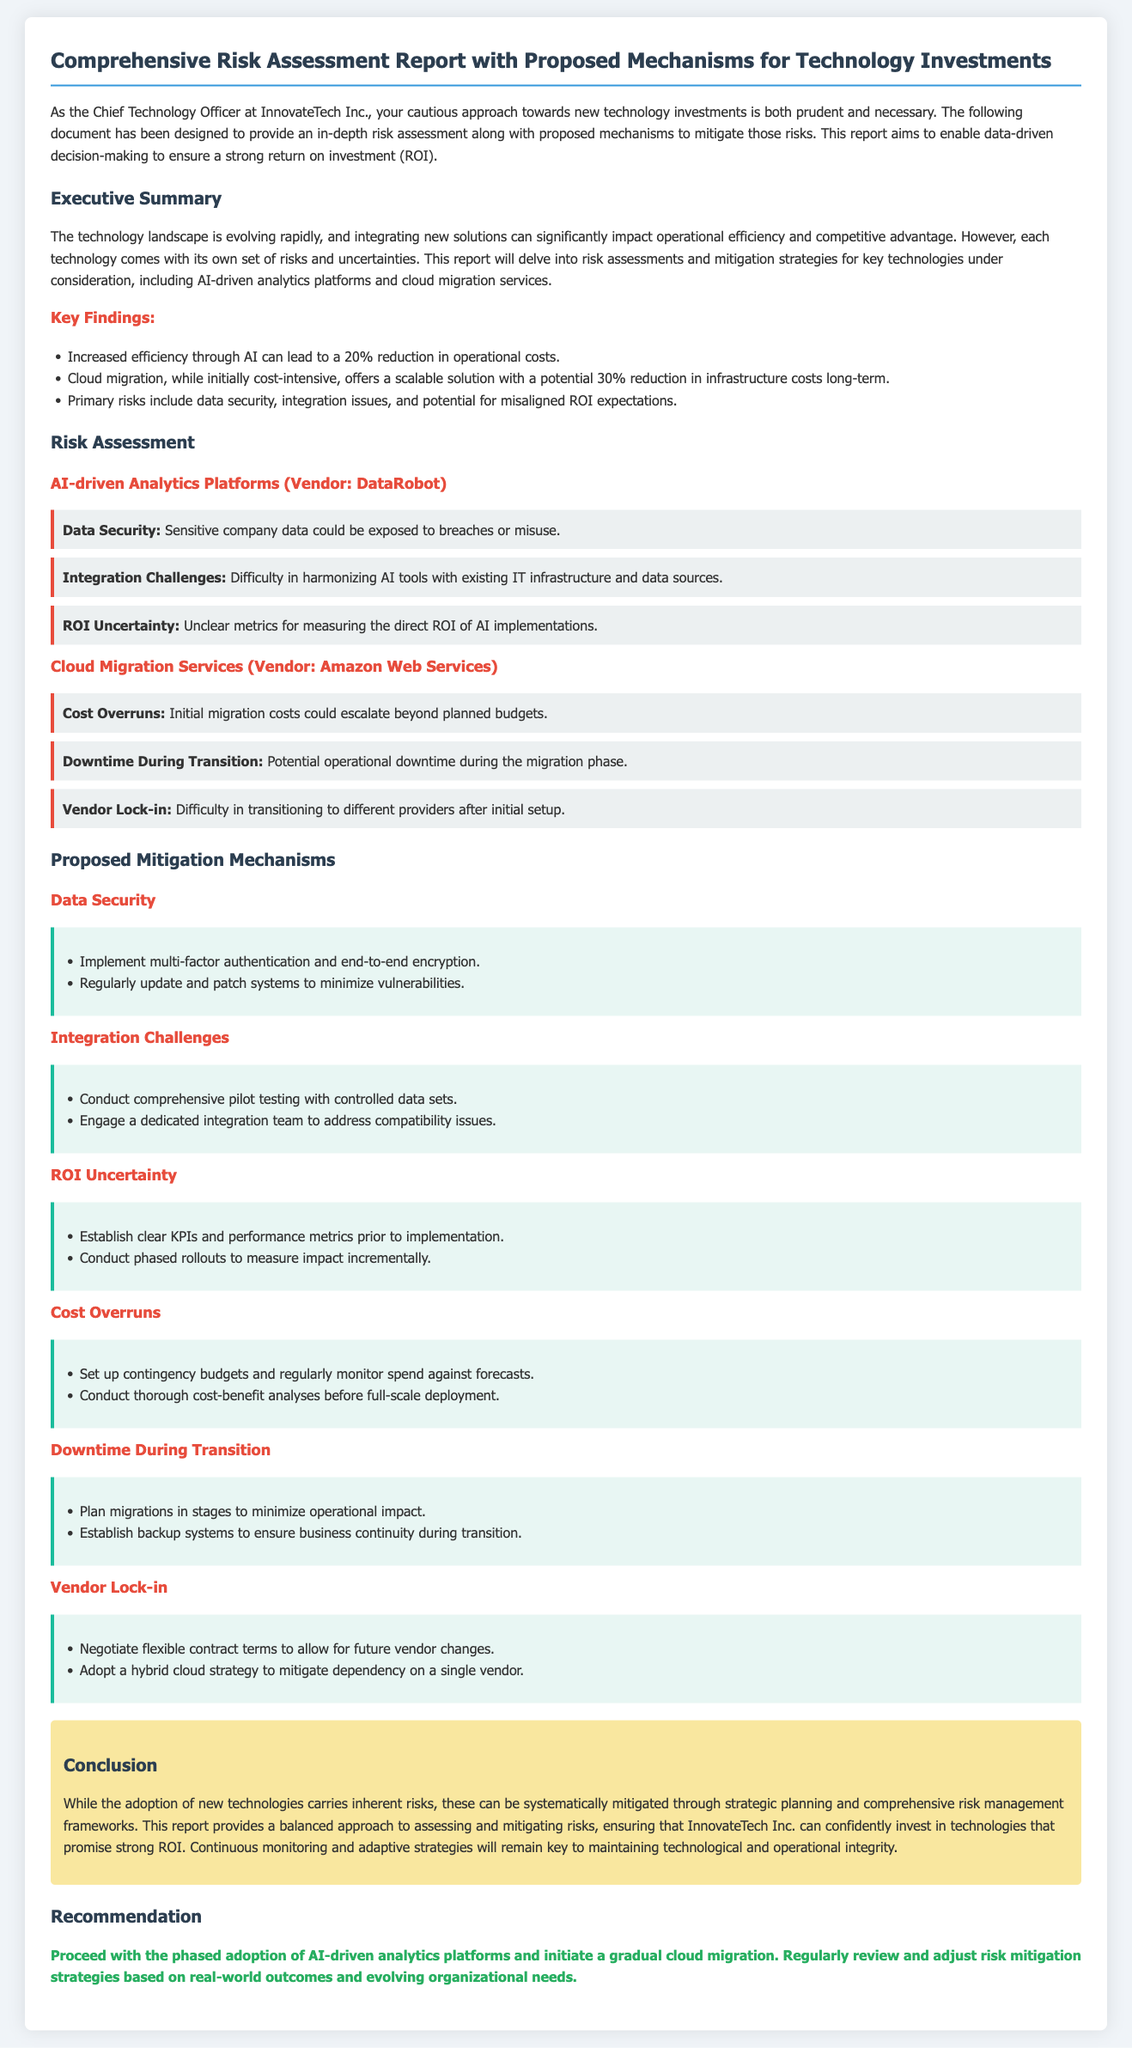what is the title of the document? The title is stated at the top of the document, which reads "Comprehensive Risk Assessment Report with Proposed Mechanisms for Technology Investments."
Answer: Comprehensive Risk Assessment Report with Proposed Mechanisms for Technology Investments which company is the report for? The report explicitly mentions that it is for InnovateTech Inc.
Answer: InnovateTech Inc what is the primary risk associated with AI-driven analytics platforms? The risk outlined in the document includes "Data Security" as a primary concern for AI-driven analytics platforms.
Answer: Data Security what is the expected reduction in operational costs from AI adoption? The document states that AI can lead to a 20% reduction in operational costs.
Answer: 20% what mechanism is suggested to mitigate downtime during cloud migration? The document recommends planning migrations in stages to minimize operational impact.
Answer: Plan migrations in stages what is one proposed mitigation for ROI uncertainty? The report suggests establishing clear KPIs and performance metrics prior to implementation.
Answer: Establish clear KPIs and performance metrics what is the contractor mentioned for cloud migration services? The document specifies that Amazon Web Services is the vendor for cloud migration services.
Answer: Amazon Web Services what should be monitored regularly to manage costs during migration? The document notes that spending should be regularly monitored against forecasts.
Answer: Regularly monitor spend against forecasts what is the conclusion of the document regarding technology adoption? The conclusion emphasizes systematic risk mitigation to confidently invest in technologies.
Answer: Systematic risk mitigation 